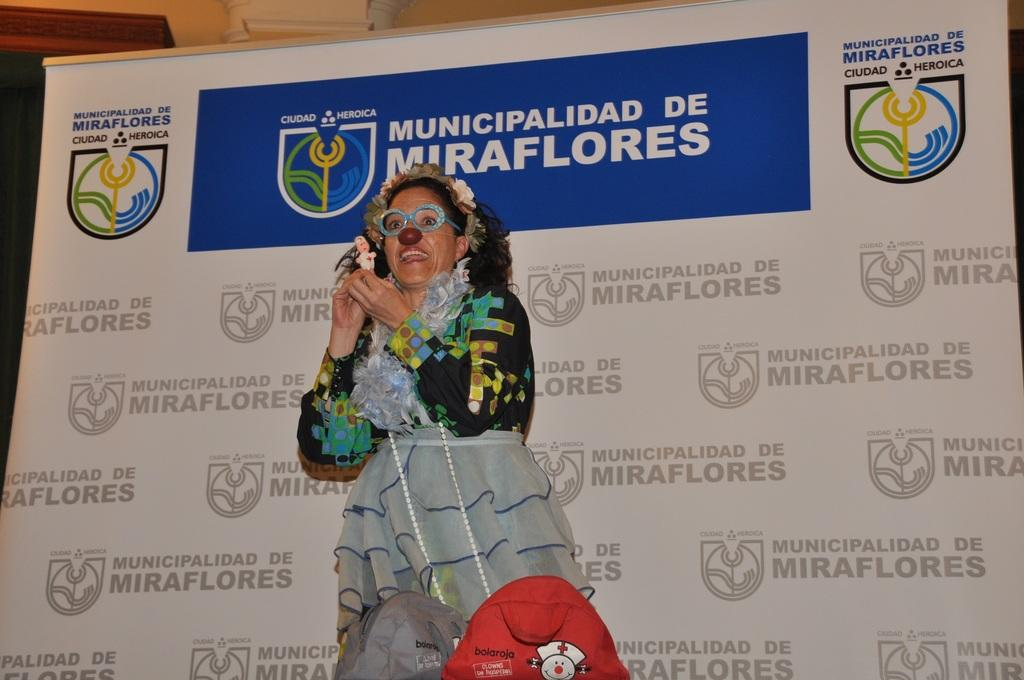Who is present in the image? There is a woman in the image. What is the woman holding in the image? The woman is holding a toy. What else can be seen in the image besides the woman and the toy? There is a banner in the image. Can you describe any other objects in the image? There are objects in the image, but their specific nature is not mentioned in the provided facts. What type of toothpaste is being used to glue the bushes together in the image? There are no bushes, toothpaste, or glue present in the image. 